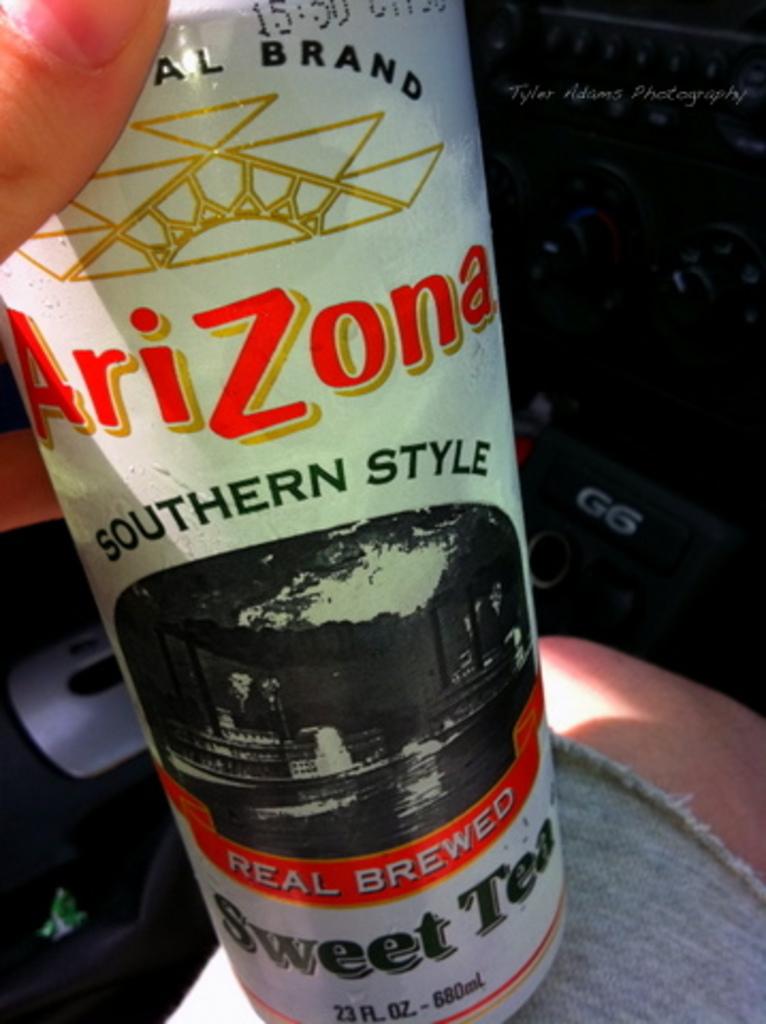What is the name of the sweet tea?
Ensure brevity in your answer.  Arizona. What style of sweet tea is this?
Keep it short and to the point. Southern style. 